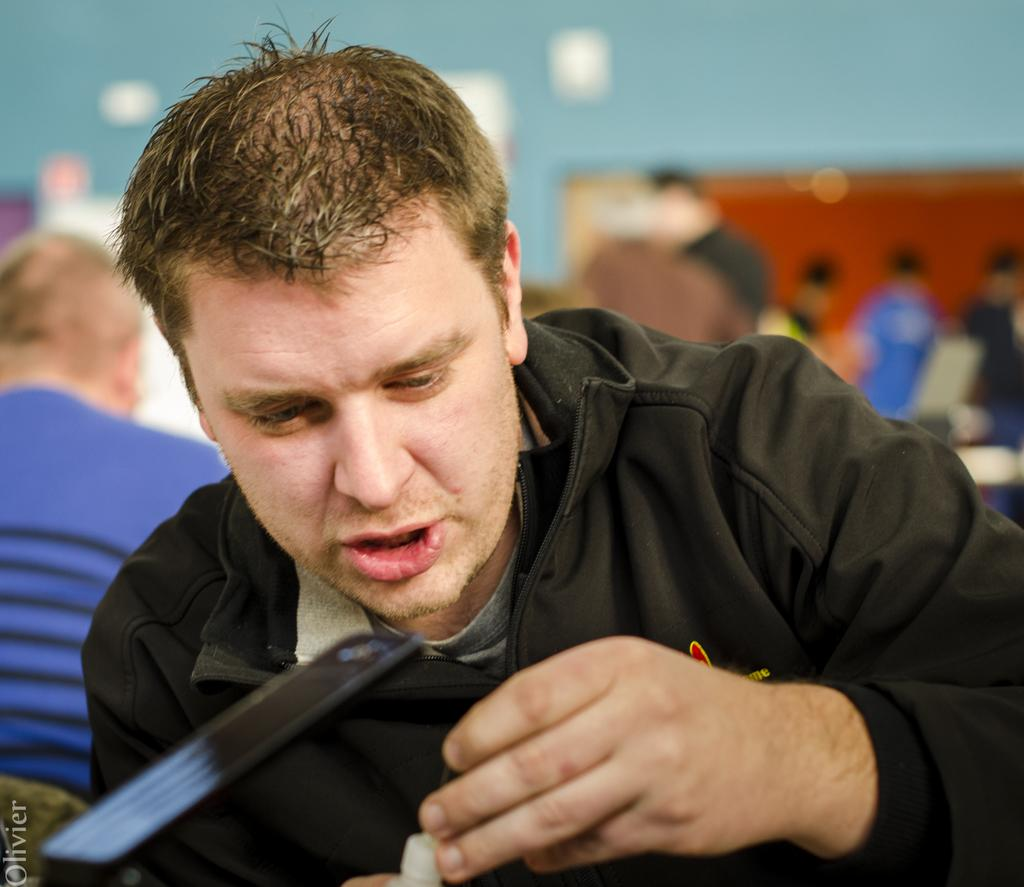Who is the main subject in the image? There is a man in the front of the image. What is the man holding in the image? The man is holding something. What can be seen in the background of the image? There is a wall and people in the background of the image. How would you describe the background of the image? The background appears blurry. What type of mine can be seen in the background of the image? There is no mine present in the image; the background features a wall and people. 